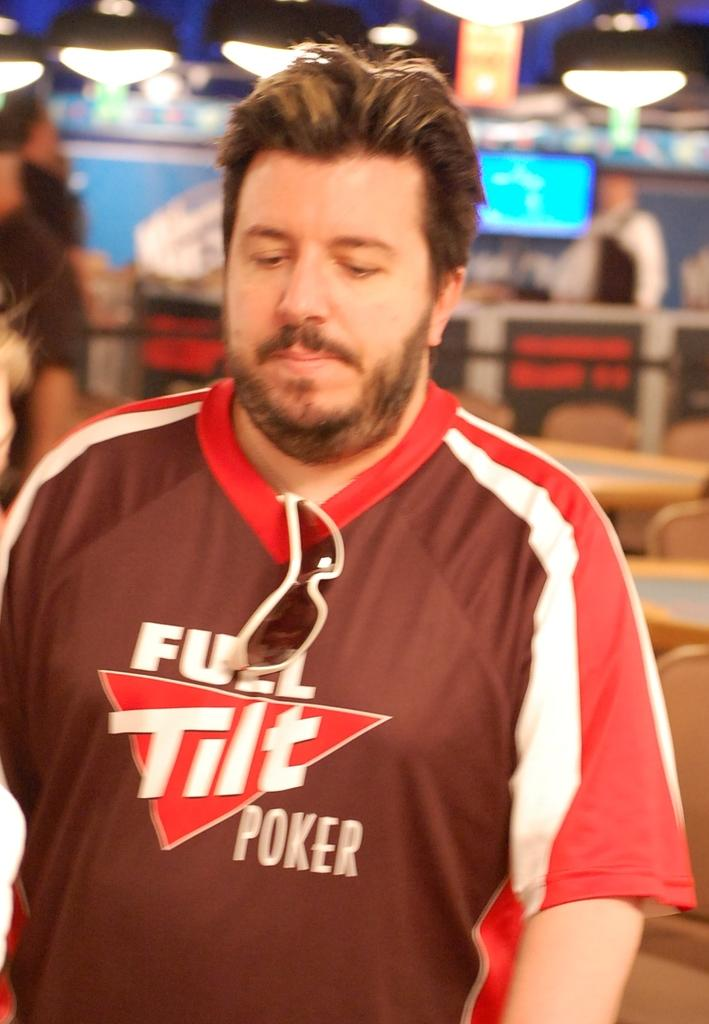<image>
Provide a brief description of the given image. A man wears a Full Tilt Poker t-shirt. 